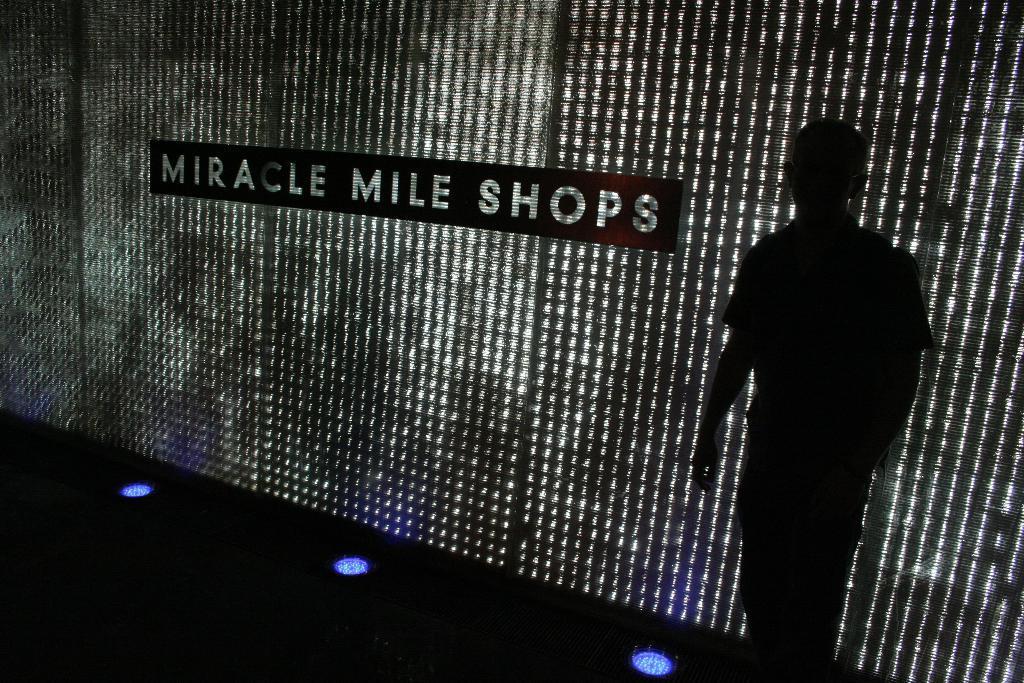Describe this image in one or two sentences. In this picture there is a man standing. At the back there is text on the wall. At the bottom there are lights. 